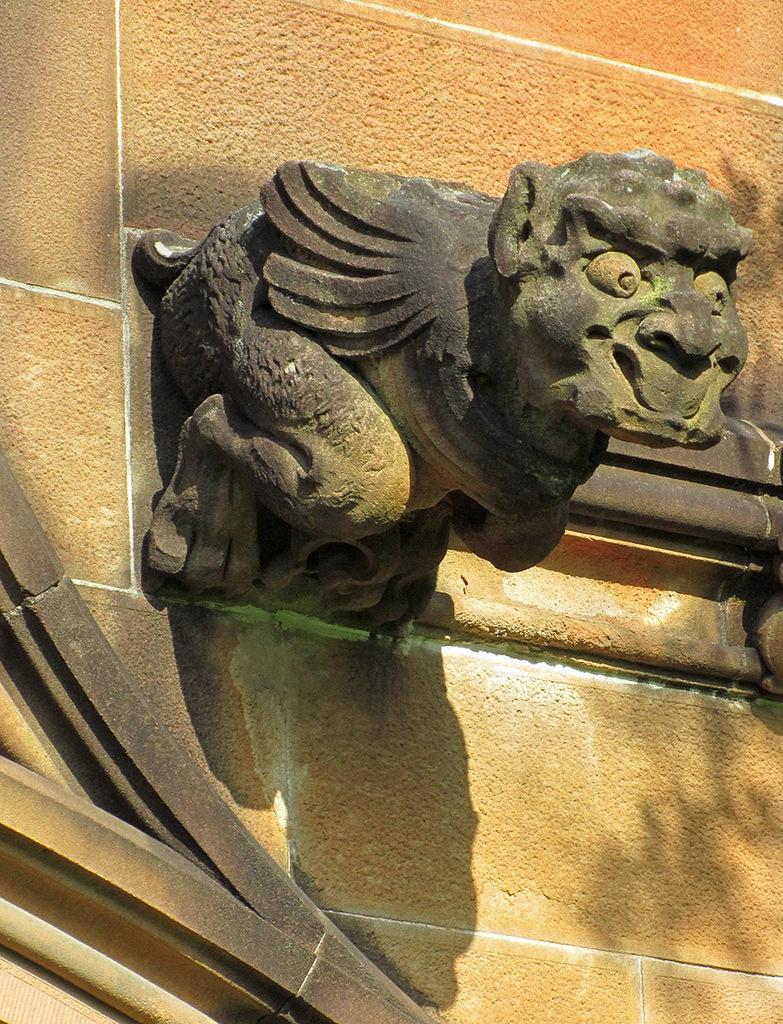What is the main subject of the image? There is a statue of a monkey in the image. What can be seen behind the statue? There is a brown wall visible in the image. What book is the monkey holding in the image? There is no book present in the image; the statue of the monkey is not holding anything. 